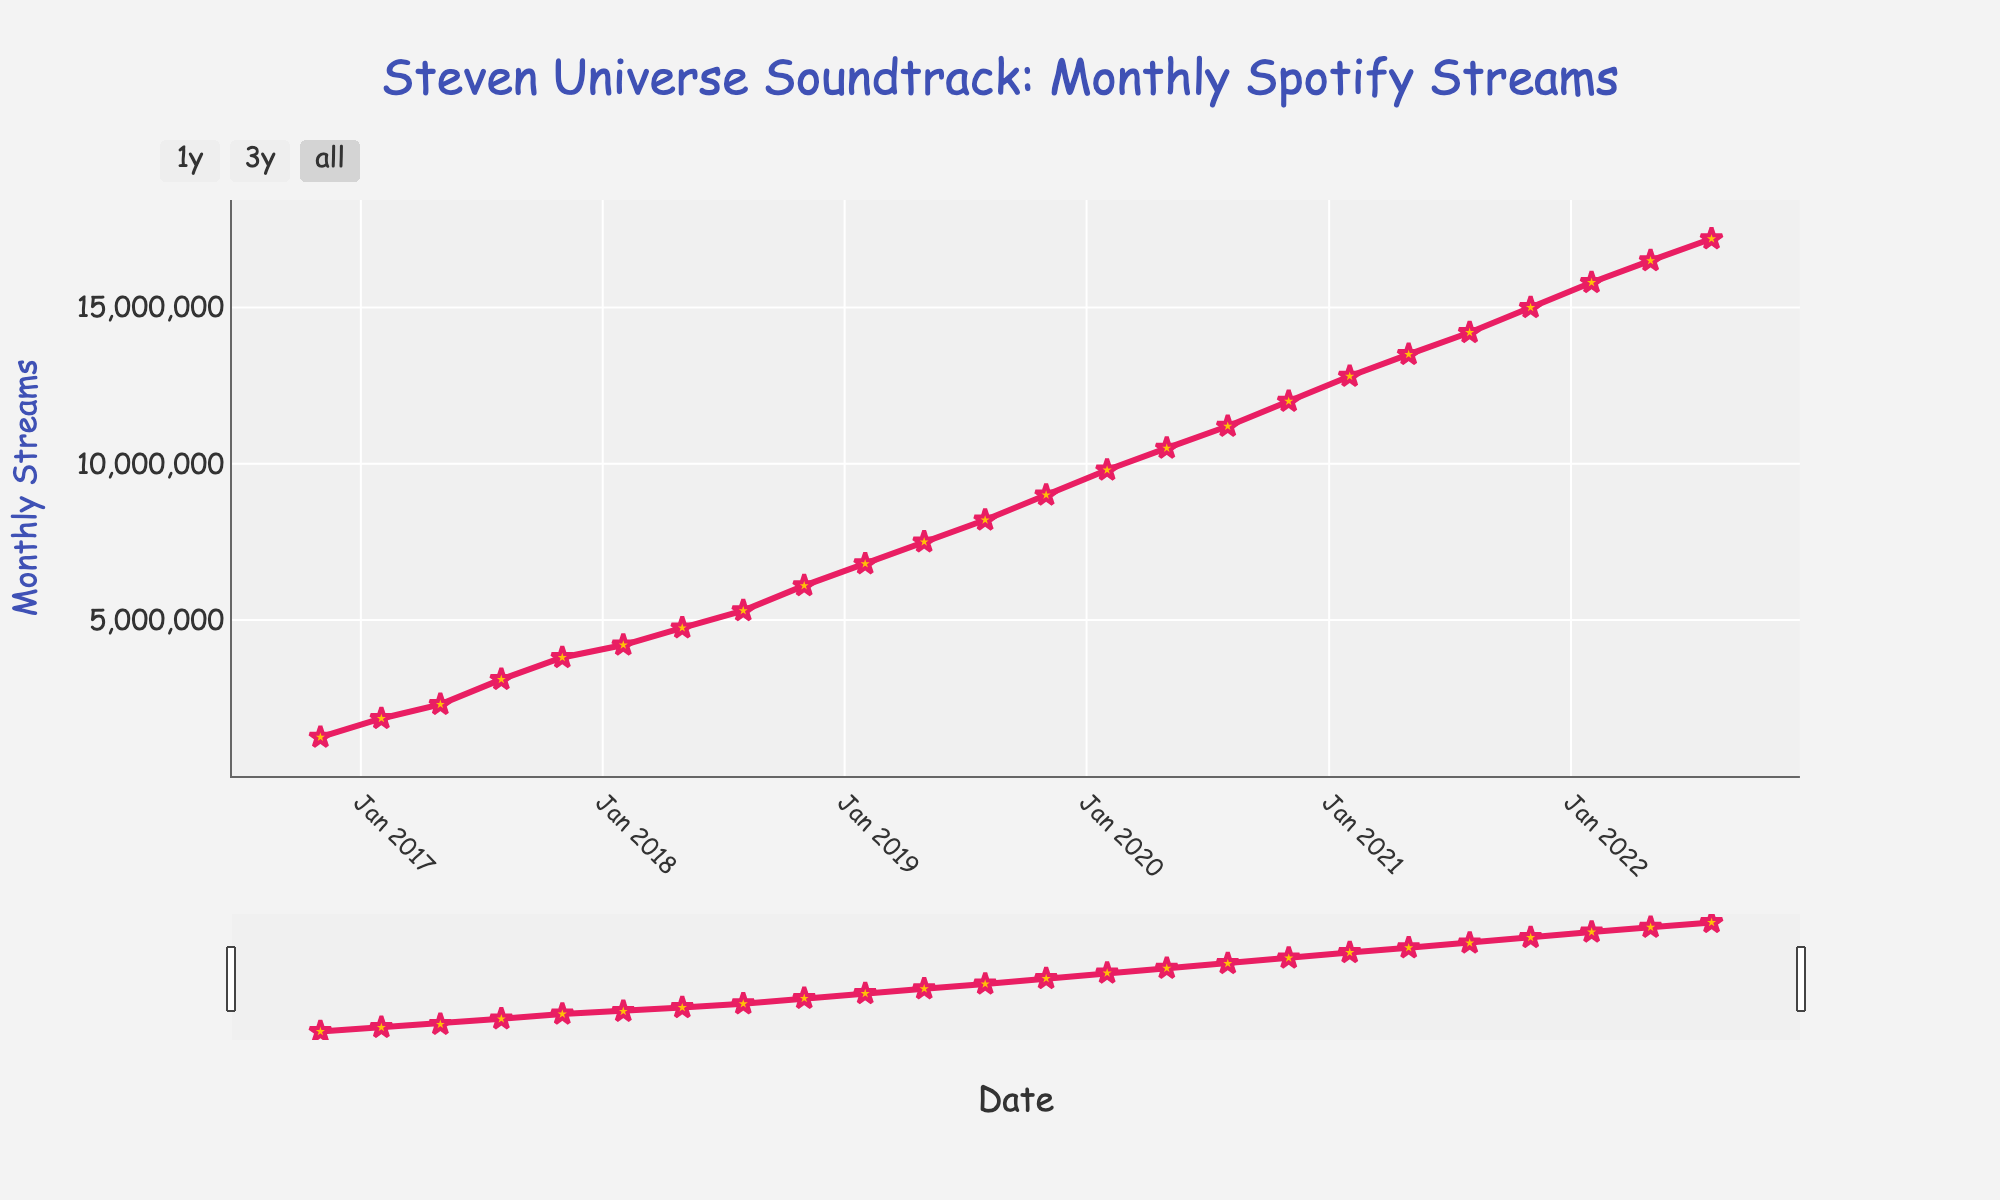what is the general trend of the monthly streams for the Steven Universe soundtrack from November 2016 to August 2022? The general trend refers to the overall direction of the monthly streams over the given period. Observing the data, the number of monthly streams increases consistently from 1.25 million in November 2016 to 17.2 million in August 2022, indicating a steady upward trend.
Answer: An upward trend What is the increase in monthly streams from February 2017 to February 2018? To find the increase, subtract the number of streams in February 2017 from the number of streams in February 2018. February 2017 has 1.85 million streams, and February 2018 has 4.2 million streams. The increase is 4.2 million - 1.85 million = 2.35 million streams.
Answer: 2.35 million What is the highest monthly stream count, and in which month did it occur? Identify the peak value in the y-axis (Monthly Streams) and note the corresponding x-axis (Date). The highest count is 17.2 million streams, which occurred in August 2022.
Answer: 17.2 million, August 2022 By how much did the monthly streams increase from November 2018 to November 2020? Subtract the stream count in November 2018 from the count in November 2020. November 2018 had 6.1 million streams, and November 2020 had 12 million streams. Increase = 12 million - 6.1 million = 5.9 million streams.
Answer: 5.9 million What is the approximate average increase in monthly streams per year from November 2016 to August 2022? First, determine the total duration in years, which is approximately 5.75 years. Calculate the total increase: 17.2 million (August 2022) - 1.25 million (November 2016) = 15.95 million streams. Divide by the number of years: 15.95 million / 5.75 ≈ 2.77 million streams per year.
Answer: ~2.77 million streams per year Which three-month period shows the highest increase in monthly streams? To find this, calculate the difference in streams between each three-month period and identify the maximum. The largest increase occurs from May 2022 (16.5 million) to August 2022 (17.2 million), resulting in an increase of 0.7 million streams.
Answer: May 2022 to August 2022 What is the visual attribute of the markers used in the plot? The visual attribute refers to the appearance of the markers. The markers are star-shaped, have a golden color, and are surrounded by a red border.
Answer: Star-shaped, golden, red border 